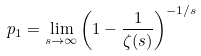<formula> <loc_0><loc_0><loc_500><loc_500>p _ { 1 } = \lim _ { s \to \infty } \left ( 1 - \frac { 1 } { \zeta ( s ) } \right ) ^ { - 1 / s }</formula> 